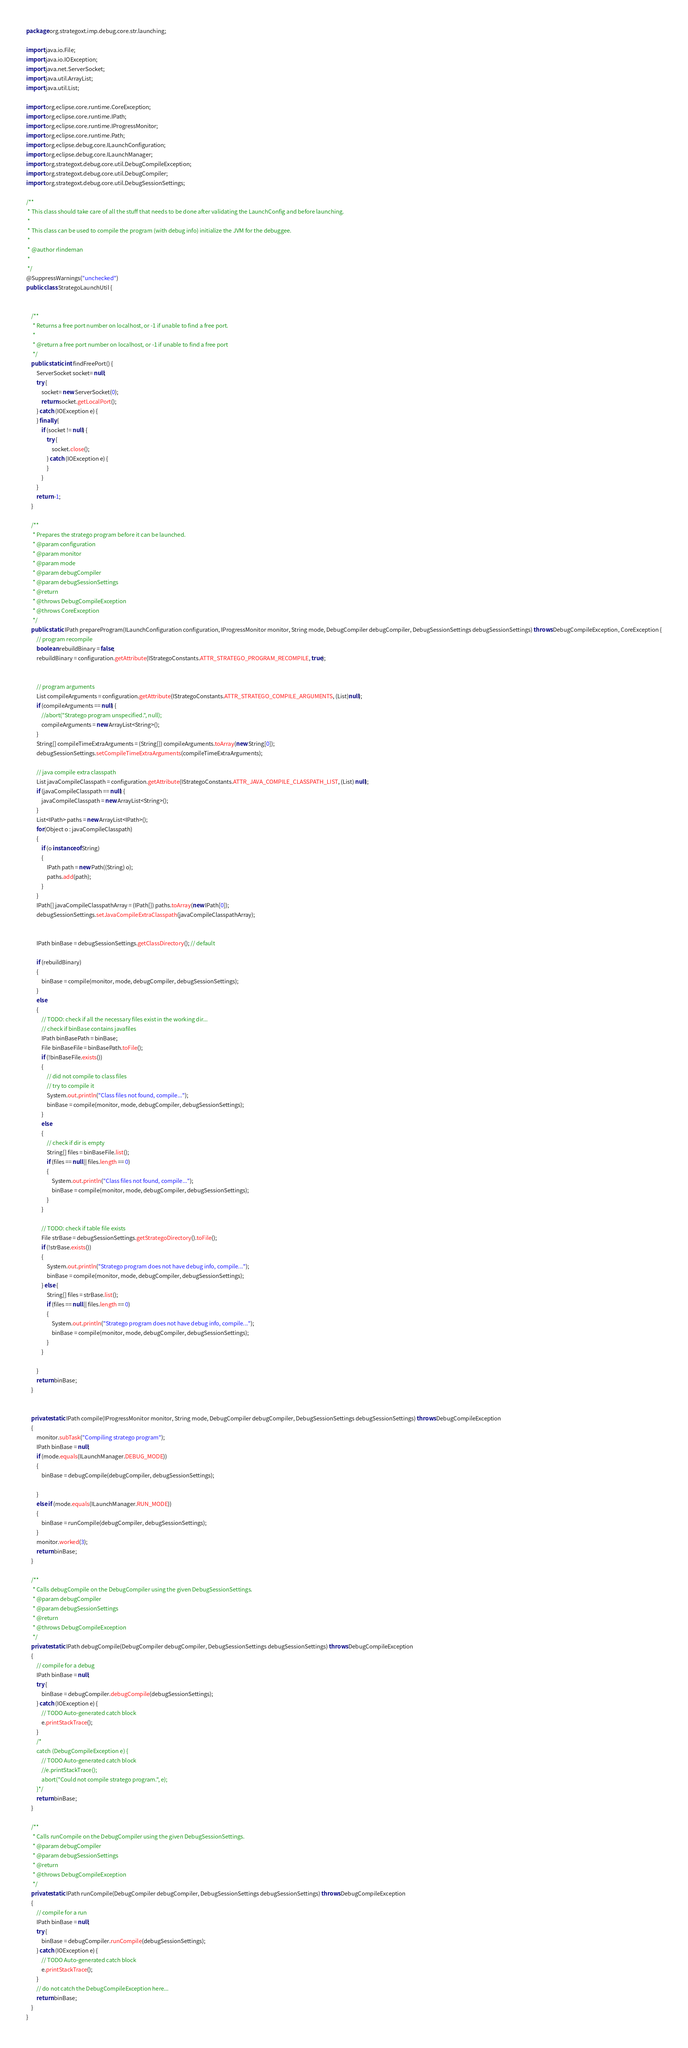<code> <loc_0><loc_0><loc_500><loc_500><_Java_>package org.strategoxt.imp.debug.core.str.launching;

import java.io.File;
import java.io.IOException;
import java.net.ServerSocket;
import java.util.ArrayList;
import java.util.List;

import org.eclipse.core.runtime.CoreException;
import org.eclipse.core.runtime.IPath;
import org.eclipse.core.runtime.IProgressMonitor;
import org.eclipse.core.runtime.Path;
import org.eclipse.debug.core.ILaunchConfiguration;
import org.eclipse.debug.core.ILaunchManager;
import org.strategoxt.debug.core.util.DebugCompileException;
import org.strategoxt.debug.core.util.DebugCompiler;
import org.strategoxt.debug.core.util.DebugSessionSettings;

/**
 * This class should take care of all the stuff that needs to be done after validating the LaunchConfig and before launching.
 * 
 * This class can be used to compile the program (with debug info) initialize the JVM for the debuggee.
 * 
 * @author rlindeman
 *
 */
@SuppressWarnings("unchecked")
public class StrategoLaunchUtil {

	
	/**
	 * Returns a free port number on localhost, or -1 if unable to find a free port.
	 * 
	 * @return a free port number on localhost, or -1 if unable to find a free port
	 */
	public static int findFreePort() {
		ServerSocket socket= null;
		try {
			socket= new ServerSocket(0);
			return socket.getLocalPort();
		} catch (IOException e) { 
		} finally {
			if (socket != null) {
				try {
					socket.close();
				} catch (IOException e) {
				}
			}
		}
		return -1;		
	}
	
	/**
	 * Prepares the stratego program before it can be launched.
	 * @param configuration
	 * @param monitor
	 * @param mode
	 * @param debugCompiler
	 * @param debugSessionSettings
	 * @return
	 * @throws DebugCompileException
	 * @throws CoreException
	 */
	public static IPath prepareProgram(ILaunchConfiguration configuration, IProgressMonitor monitor, String mode, DebugCompiler debugCompiler, DebugSessionSettings debugSessionSettings) throws DebugCompileException, CoreException {
		// program recompile
		boolean rebuildBinary = false;
		rebuildBinary = configuration.getAttribute(IStrategoConstants.ATTR_STRATEGO_PROGRAM_RECOMPILE, true);


		// program arguments
		List compileArguments = configuration.getAttribute(IStrategoConstants.ATTR_STRATEGO_COMPILE_ARGUMENTS, (List)null);
		if (compileArguments == null) {
			//abort("Stratego program unspecified.", null);
			compileArguments = new ArrayList<String>();
		}
		String[] compileTimeExtraArguments = (String[]) compileArguments.toArray(new String[0]);
		debugSessionSettings.setCompileTimeExtraArguments(compileTimeExtraArguments);
		
		// java compile extra classpath
		List javaCompileClasspath = configuration.getAttribute(IStrategoConstants.ATTR_JAVA_COMPILE_CLASSPATH_LIST, (List) null);
		if (javaCompileClasspath == null) {
			javaCompileClasspath = new ArrayList<String>();
		}
		List<IPath> paths = new ArrayList<IPath>();
		for(Object o : javaCompileClasspath)
		{
			if (o instanceof String)
			{
				IPath path = new Path((String) o);
				paths.add(path);
			}
		}
		IPath[] javaCompileClasspathArray = (IPath[]) paths.toArray(new IPath[0]);
		debugSessionSettings.setJavaCompileExtraClasspath(javaCompileClasspathArray);
		
		
		IPath binBase = debugSessionSettings.getClassDirectory(); // default

		if (rebuildBinary)
		{
			binBase = compile(monitor, mode, debugCompiler, debugSessionSettings);
		}
		else
		{
			// TODO: check if all the necessary files exist in the working dir...
			// check if binBase contains javafiles
			IPath binBasePath = binBase;
			File binBaseFile = binBasePath.toFile();
			if (!binBaseFile.exists())
			{
				// did not compile to class files
				// try to compile it
				System.out.println("Class files not found, compile...");
				binBase = compile(monitor, mode, debugCompiler, debugSessionSettings);
			}
			else
			{
				// check if dir is empty
				String[] files = binBaseFile.list();
				if (files == null || files.length == 0)
				{
					System.out.println("Class files not found, compile...");
					binBase = compile(monitor, mode, debugCompiler, debugSessionSettings);
				}
			}
			
			// TODO: check if table file exists
			File strBase = debugSessionSettings.getStrategoDirectory().toFile();
			if (!strBase.exists())
			{
				System.out.println("Stratego program does not have debug info, compile...");
				binBase = compile(monitor, mode, debugCompiler, debugSessionSettings);
			} else {
				String[] files = strBase.list();
				if (files == null || files.length == 0)
				{
					System.out.println("Stratego program does not have debug info, compile...");
					binBase = compile(monitor, mode, debugCompiler, debugSessionSettings);
				}
			}
			
		}
		return binBase;
	}
	
	
	private static IPath compile(IProgressMonitor monitor, String mode, DebugCompiler debugCompiler, DebugSessionSettings debugSessionSettings) throws DebugCompileException
	{
		monitor.subTask("Compiling stratego program");
		IPath binBase = null;
		if (mode.equals(ILaunchManager.DEBUG_MODE)) 
		{
			binBase = debugCompile(debugCompiler, debugSessionSettings);

		}
		else if (mode.equals(ILaunchManager.RUN_MODE))
		{
			binBase = runCompile(debugCompiler, debugSessionSettings);
		}
		monitor.worked(3);
		return binBase;
	}
	
	/**
	 * Calls debugCompile on the DebugCompiler using the given DebugSessionSettings.
	 * @param debugCompiler
	 * @param debugSessionSettings
	 * @return
	 * @throws DebugCompileException
	 */
	private static IPath debugCompile(DebugCompiler debugCompiler, DebugSessionSettings debugSessionSettings) throws DebugCompileException
	{
		// compile for a debug
		IPath binBase = null;
		try {
			binBase = debugCompiler.debugCompile(debugSessionSettings);
		} catch (IOException e) {
			// TODO Auto-generated catch block
			e.printStackTrace();
		} 
		/*
		catch (DebugCompileException e) {
			// TODO Auto-generated catch block
			//e.printStackTrace();
			abort("Could not compile stratego program.", e);
		}*/
		return binBase;
	}
	
	/**
	 * Calls runCompile on the DebugCompiler using the given DebugSessionSettings.
	 * @param debugCompiler
	 * @param debugSessionSettings
	 * @return
	 * @throws DebugCompileException
	 */
	private static IPath runCompile(DebugCompiler debugCompiler, DebugSessionSettings debugSessionSettings) throws DebugCompileException
	{
		// compile for a run
		IPath binBase = null;
		try {
			binBase = debugCompiler.runCompile(debugSessionSettings);
		} catch (IOException e) {
			// TODO Auto-generated catch block
			e.printStackTrace();
		} 
		// do not catch the DebugCompileException here...
		return binBase;
	}
}
</code> 